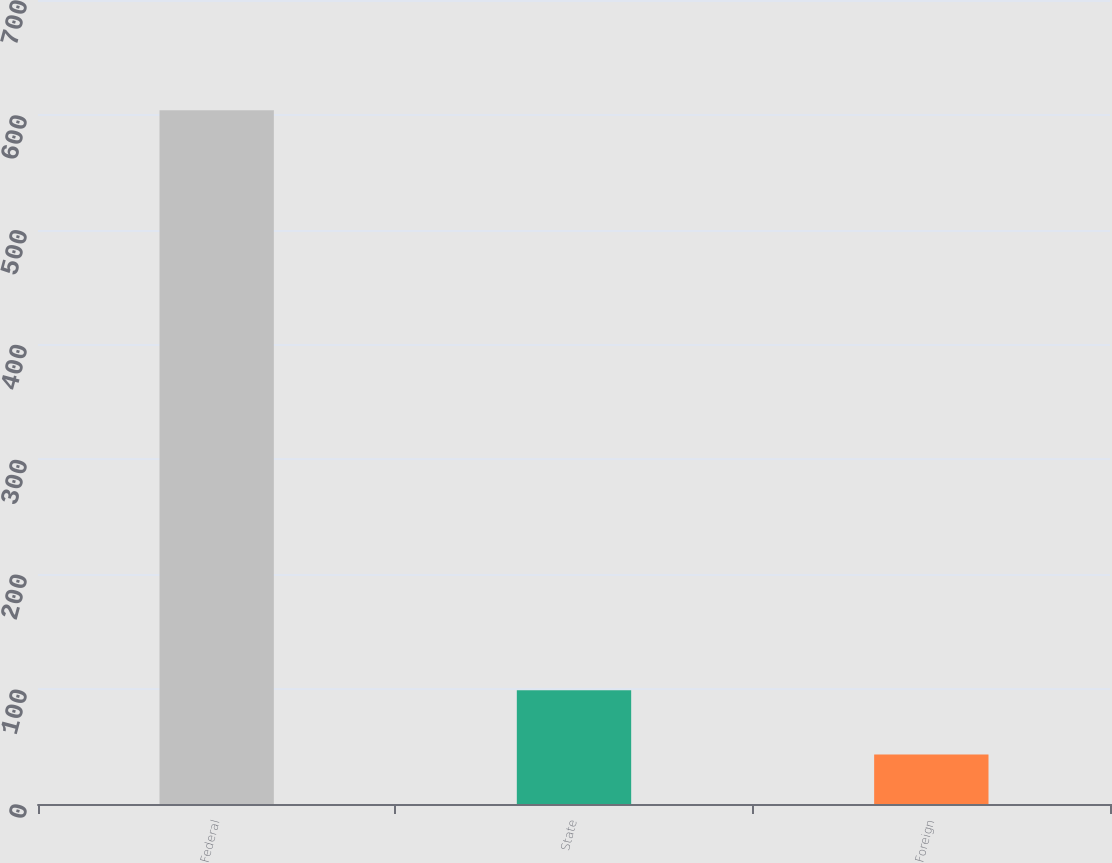<chart> <loc_0><loc_0><loc_500><loc_500><bar_chart><fcel>Federal<fcel>State<fcel>Foreign<nl><fcel>604<fcel>99.1<fcel>43<nl></chart> 